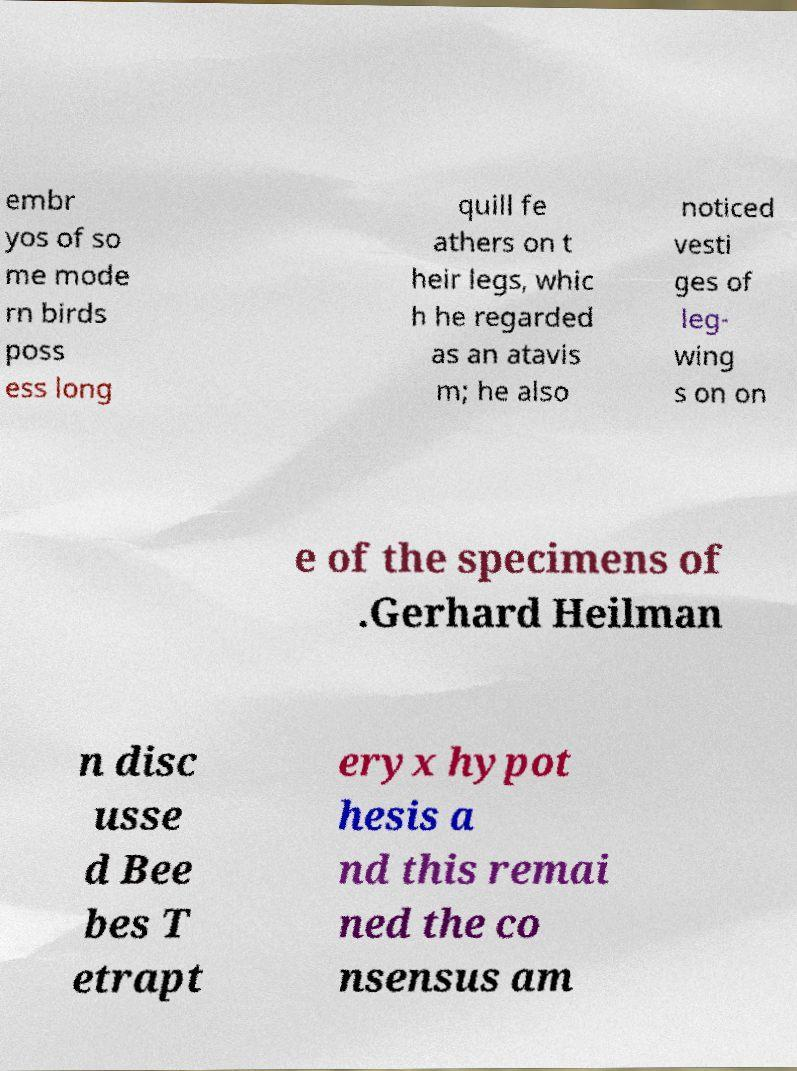There's text embedded in this image that I need extracted. Can you transcribe it verbatim? embr yos of so me mode rn birds poss ess long quill fe athers on t heir legs, whic h he regarded as an atavis m; he also noticed vesti ges of leg- wing s on on e of the specimens of .Gerhard Heilman n disc usse d Bee bes T etrapt eryx hypot hesis a nd this remai ned the co nsensus am 